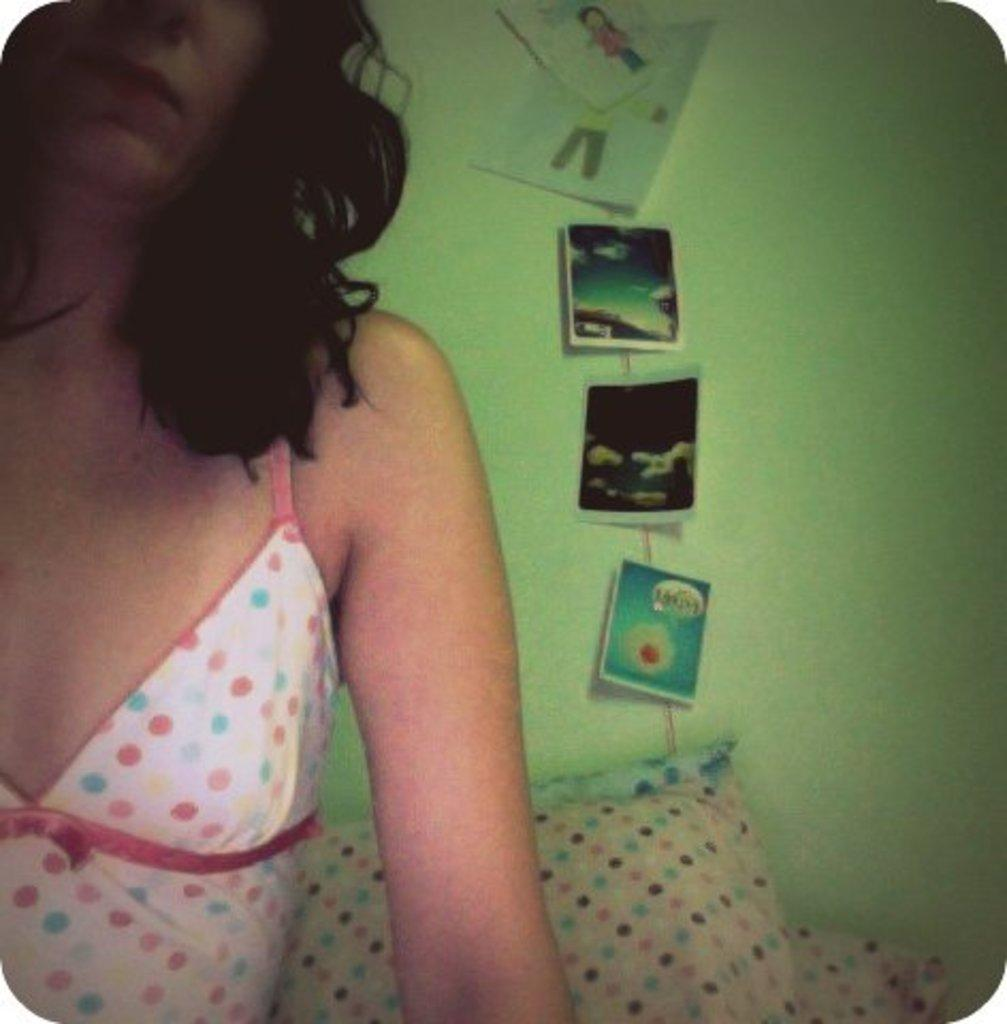Who is present in the image? There is a woman in the image. What can be seen on the floor in the image? There are pillows in the image. What is on the wall in the image? There are posters on the wall in the image. What type of pail is being used for writing in the image? There is no pail present in the image, and no writing is taking place. 